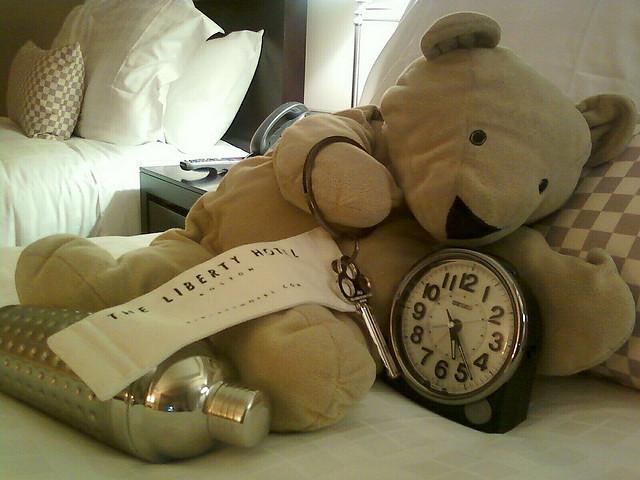What is hanging from the bear's wrist?
Choose the right answer and clarify with the format: 'Answer: answer
Rationale: rationale.'
Options: Key, watch, scissors, knife. Answer: key.
Rationale: An ornate ring with a silver key attached to it is around the wrist of a stuffed bear. 